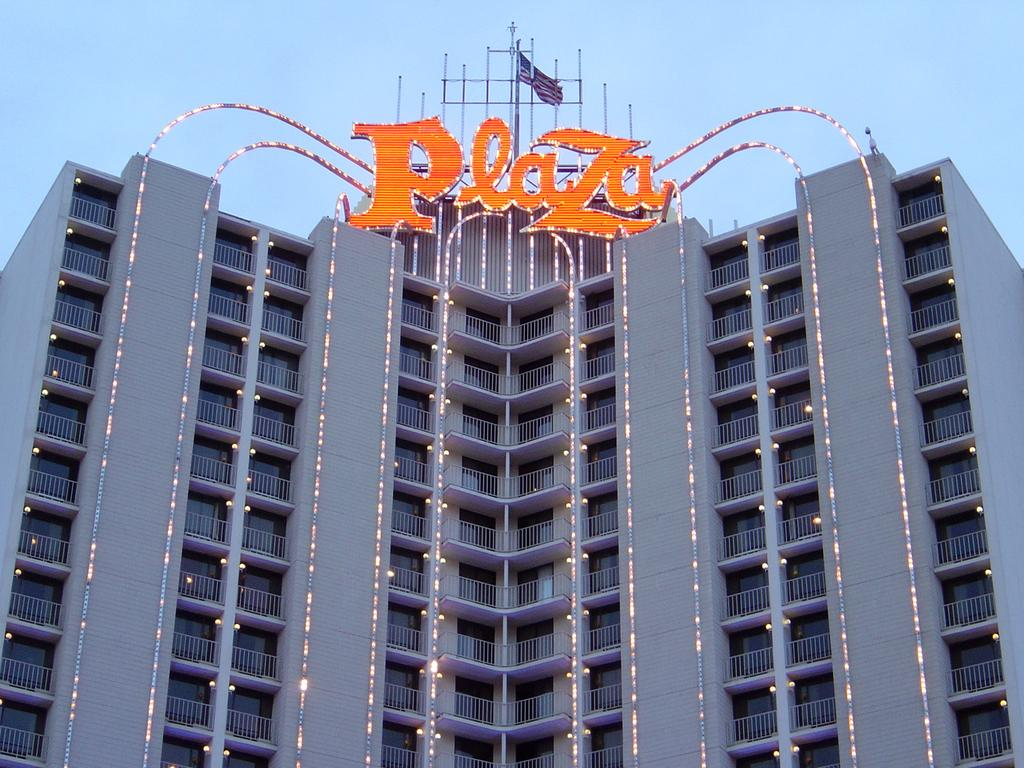What type of structure is present in the image? There is a building in the image. What feature can be seen on the building? The building has lightning. What color word is on top of the building? There is an orange color word on top of the building. What can be seen in the background of the image? The sky is visible in the image. What type of fruit is hanging from the lightning on the building? There is no fruit present in the image, and the lightning is not a physical object that could support fruit. 